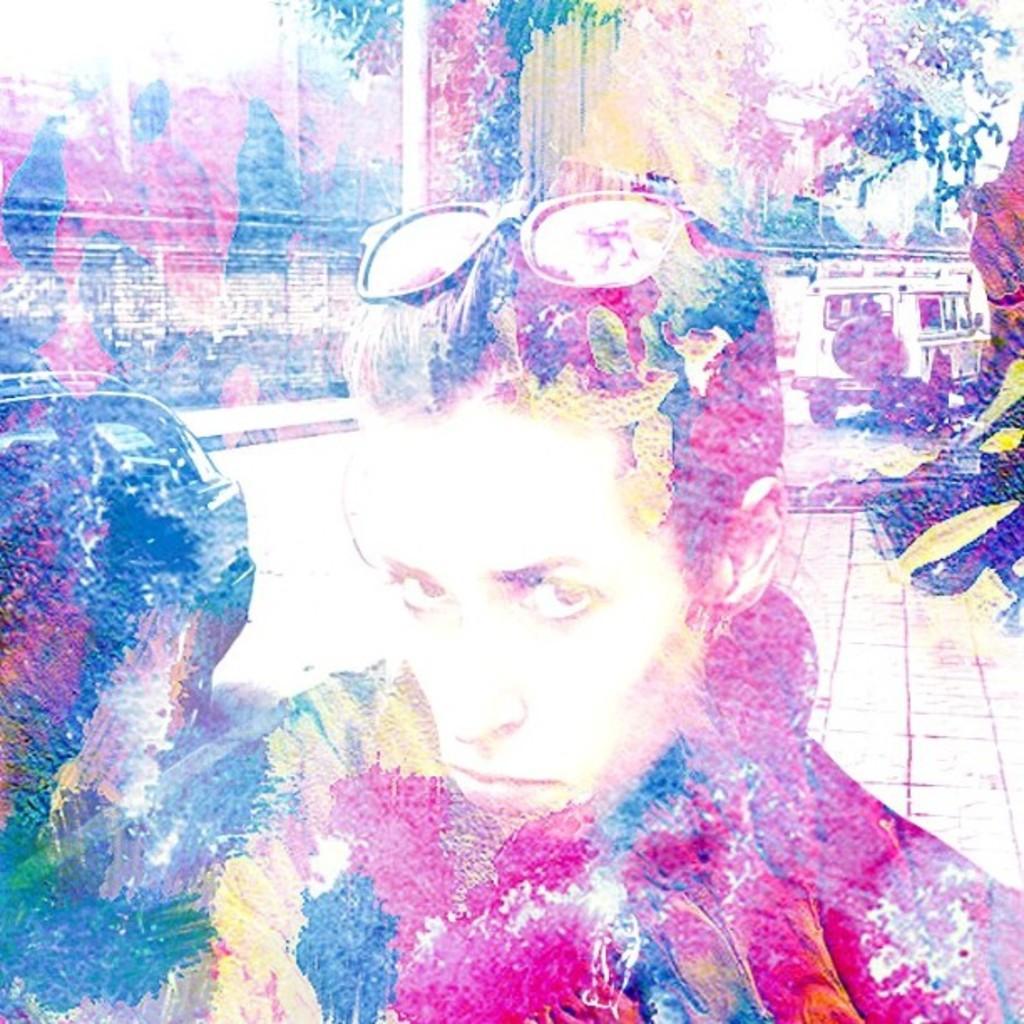Can you describe this image briefly? This is an animated image, in this image in the foreground there is one man who is wearing glasses, and in the background there are some vehicles and wall, trees and poles. 